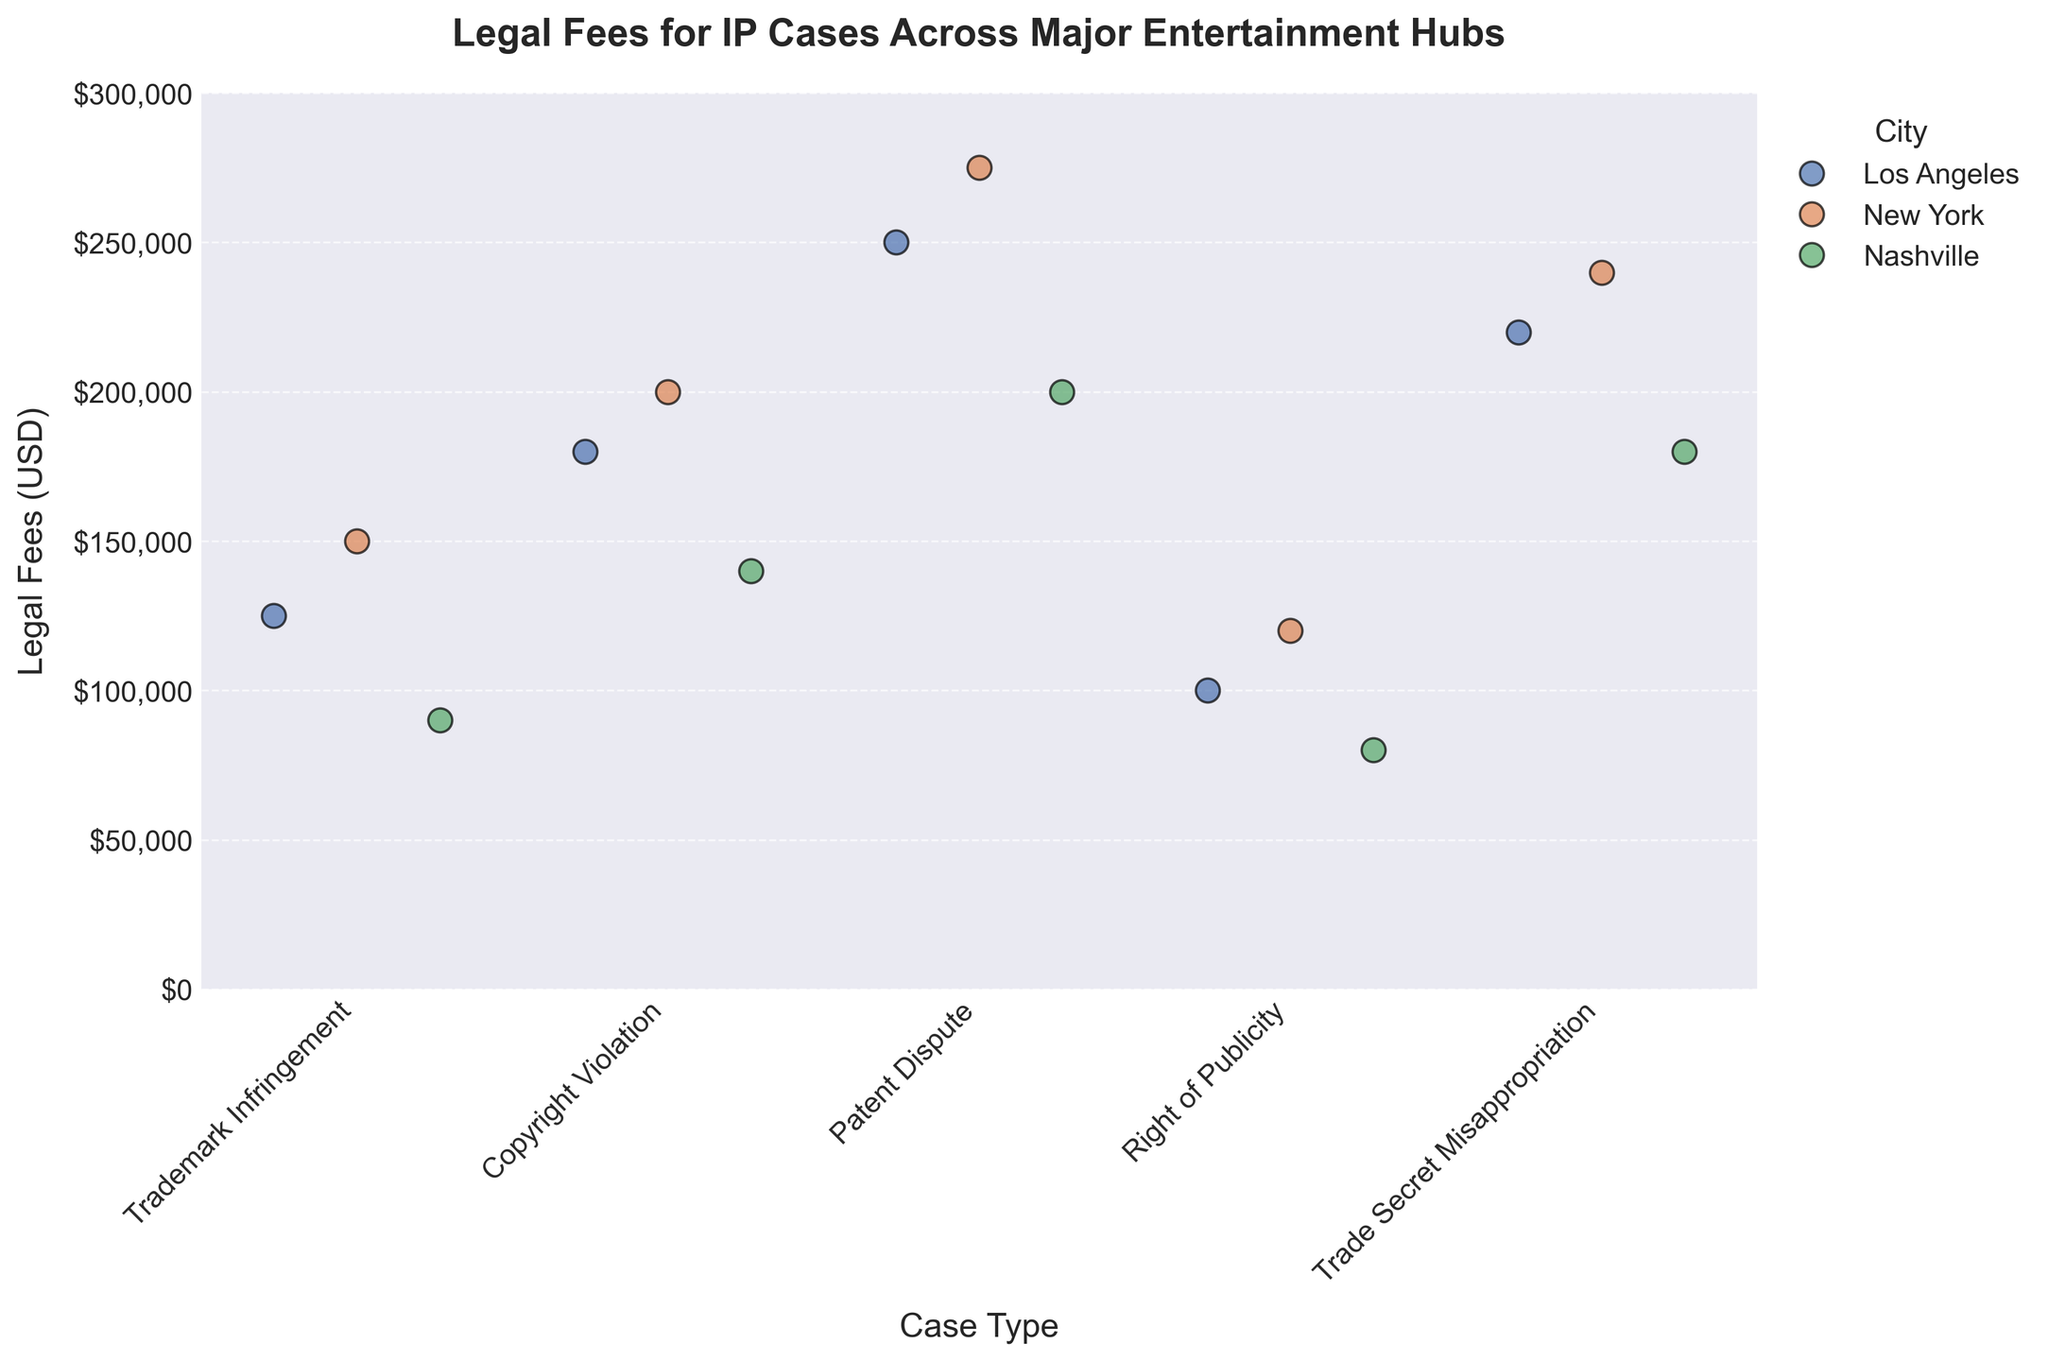How many different cities are represented in the plot? The plot uses different colors to represent cities. By looking at the legend, we can see there are three distinct city names mentioned: Los Angeles, New York, and Nashville.
Answer: 3 What city has the highest legal fee value for a Patent Dispute case? By observing the plot, the highest point for Patent Dispute cases can be noticed in the dot color that represents New York, reaching up to $275,000.
Answer: New York What is the range of legal fees for Trademark Infringement cases across all cities? To find the range, identify the highest and lowest points for Trademark Infringement cases. The highest fee is $150,000 (New York) and the lowest is $90,000 (Nashville). The range is calculated as $150,000 - $90,000.
Answer: $60,000 Which type of IP case has the narrowest range of legal fees? To determine this, compare the range for all case types. The tightest clustering occurs with Right of Publicity cases, with values ranging from $80,000 to $120,000.
Answer: Right of Publicity Comparing Los Angeles and Nashville, which city has higher average legal fees for Trade Secret Misappropriation cases? For Los Angeles, the legal fee is $220,000. For Nashville, it is $180,000. Averaging them directly gives higher fees for Los Angeles.
Answer: Los Angeles Which case type typically incurs higher legal fees, Right of Publicity or Trade Secret Misappropriation? To answer, compare the values for both case types. Trade Secret Misappropriation fees are clustered around higher values ($220,000, $240,000, $180,000) than Right of Publicity fees ($100,000, $120,000, $80,000).
Answer: Trade Secret Misappropriation What is the average legal fee for Copyright Violation cases across all cities? Sum the fees for Copyright Violation cases: $180,000 (LA) + $200,000 (NY) + $140,000 (Nashville) = $520,000. Divide this by 3 to get the average.
Answer: $173,333 In which city do Patent Dispute cases cost the least on average, and what is that average? Sum the fees for Patent Dispute cases per city and divide by the number of points (3). For Nashville: $200,000, Los Angeles: $250,000, New York: $275,000. Nashville has the lowest average.
Answer: Nashville, $200,000 Excluding outliers, which city has the most expensive overall legal fees for IP cases? By visually averaging the clusters of points for each city, New York consistently shows higher average fees across various case types compared to Los Angeles and Nashville.
Answer: New York 